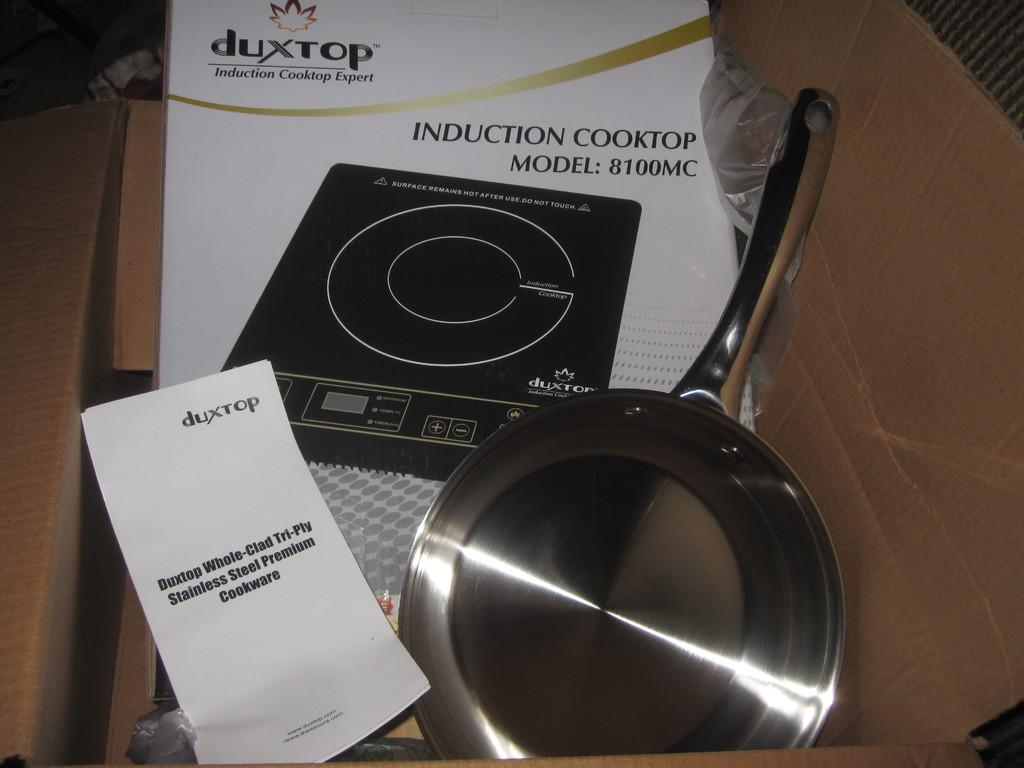What is one of the main objects in the image? There is a pan in the image. What type of material is present in the image? There is paper and a sheet in the image. What is the arrangement of the objects in the image? The objects are placed in a cardboard box. Can you describe any other objects in the image? Yes, there are other objects in the image. What is the relation between the egg and the color blue in the image? There is no egg or color blue present in the image. 